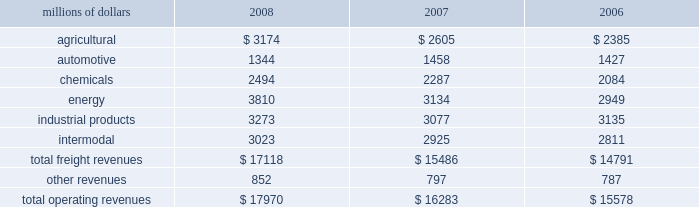Notes to the consolidated financial statements union pacific corporation and subsidiary companies for purposes of this report , unless the context otherwise requires , all references herein to the 201ccorporation 201d , 201cupc 201d , 201cwe 201d , 201cus 201d , and 201cour 201d mean union pacific corporation and its subsidiaries , including union pacific railroad company , which will be separately referred to herein as 201cuprr 201d or the 201crailroad 201d .
Nature of operations and significant accounting policies operations and segmentation 2013 we are a class i railroad that operates in the united states .
We have 32012 route miles , linking pacific coast and gulf coast ports with the midwest and eastern united states gateways and providing several corridors to key mexican gateways .
We serve the western two- thirds of the country and maintain coordinated schedules with other rail carriers for the handling of freight to and from the atlantic coast , the pacific coast , the southeast , the southwest , canada , and mexico .
Export and import traffic is moved through gulf coast and pacific coast ports and across the mexican and canadian borders .
The railroad , along with its subsidiaries and rail affiliates , is our one reportable operating segment .
Although revenues are analyzed by commodity group , we analyze the net financial results of the railroad as one segment due to the integrated nature of our rail network .
The table provides revenue by commodity group : millions of dollars 2008 2007 2006 .
Basis of presentation 2013 certain prior year amounts have been reclassified to conform to the current period financial statement presentation .
The reclassifications include reporting freight revenues instead of commodity revenues .
The amounts reclassified from freight revenues to other revenues totaled $ 30 million and $ 71 million for the years ended december 31 , 2007 , and december 31 , 2006 , respectively .
In addition , we modified our operating expense categories to report fuel used in railroad operations as a stand-alone category , to combine purchased services and materials into one line , and to reclassify certain other expenses among operating expense categories .
These reclassifications had no impact on previously reported operating revenues , total operating expenses , operating income or net income .
Significant accounting policies principles of consolidation 2013 the consolidated financial statements include the accounts of union pacific corporation and all of its subsidiaries .
Investments in affiliated companies ( 20% ( 20 % ) to 50% ( 50 % ) owned ) are accounted for using the equity method of accounting .
All significant intercompany transactions are eliminated .
The corporation evaluates its less than majority-owned investments for consolidation .
What percentage of total freight revenues were energy in 2007? 
Computations: (3134 / 15486)
Answer: 0.20238. 